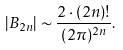<formula> <loc_0><loc_0><loc_500><loc_500>| B _ { 2 n } | \sim \frac { 2 \cdot ( 2 n ) ! } { ( 2 \pi ) ^ { 2 n } } .</formula> 